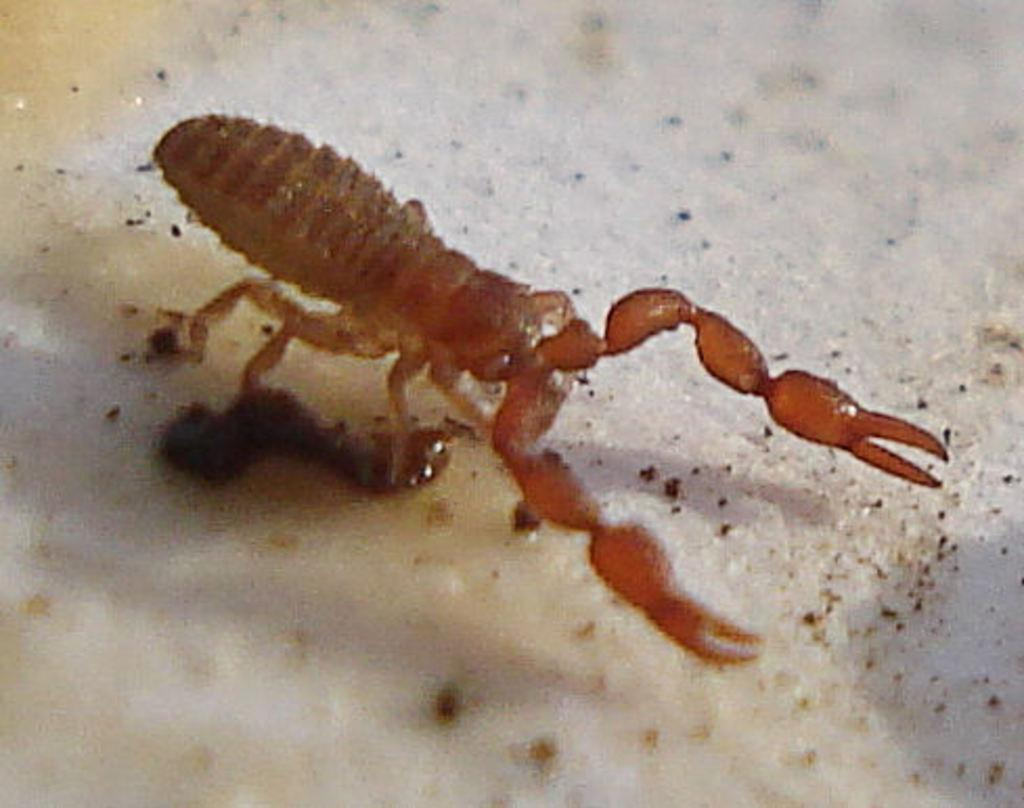What type of creature can be seen in the image? There is an insect in the image. What type of faucet is being offered to the insect in the image? There is no faucet present in the image, nor is any offer being made to the insect. 